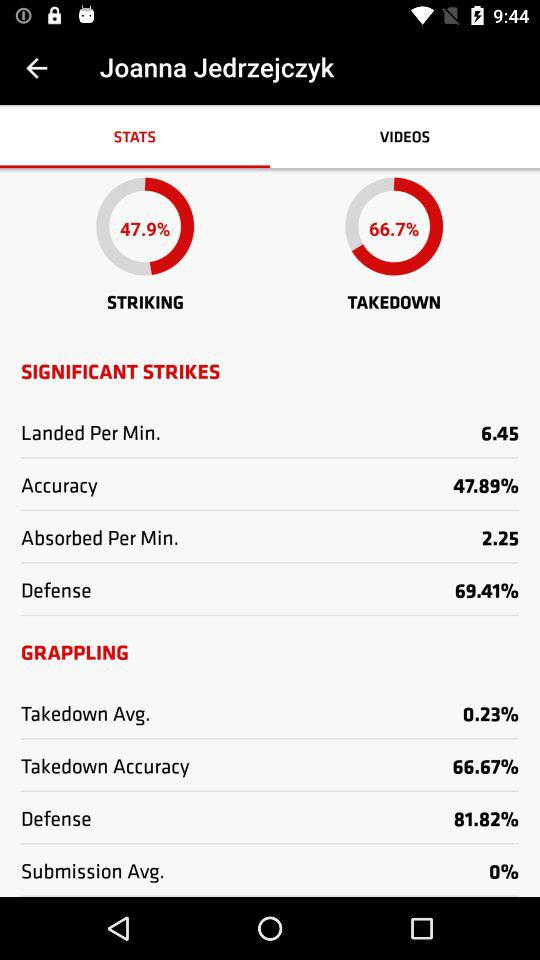What is Joanna Jedrzejczyk's takedown accuracy?
Answer the question using a single word or phrase. 66.67% 